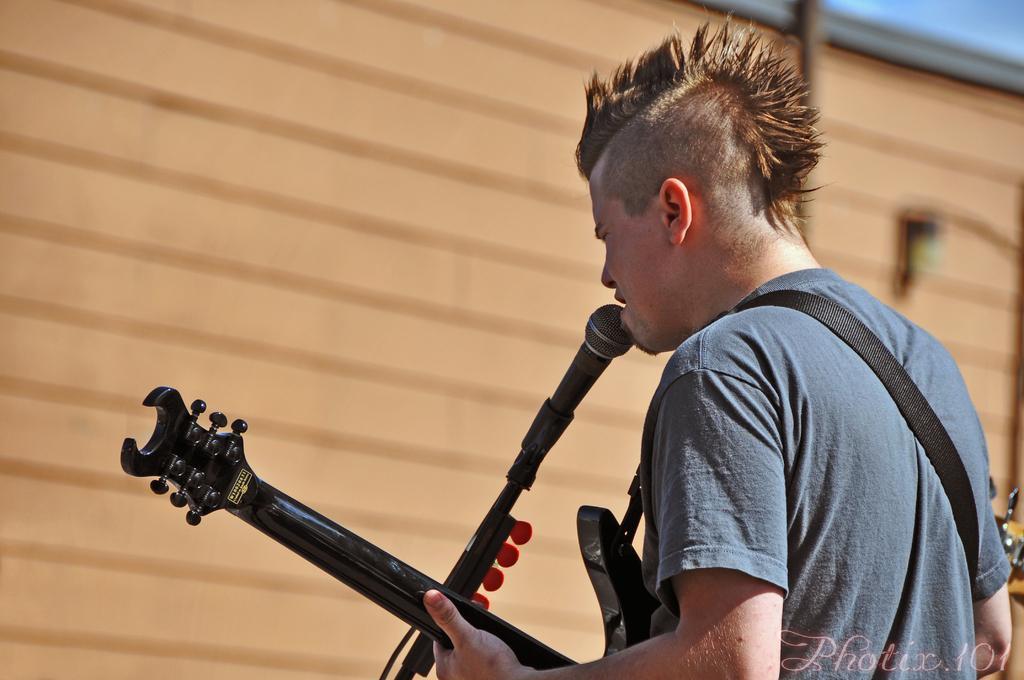In one or two sentences, can you explain what this image depicts? In this image I see a man who is holding a guitar and there is a mic in front of him, I can also see this man is wearing a blue color t-shirt. 